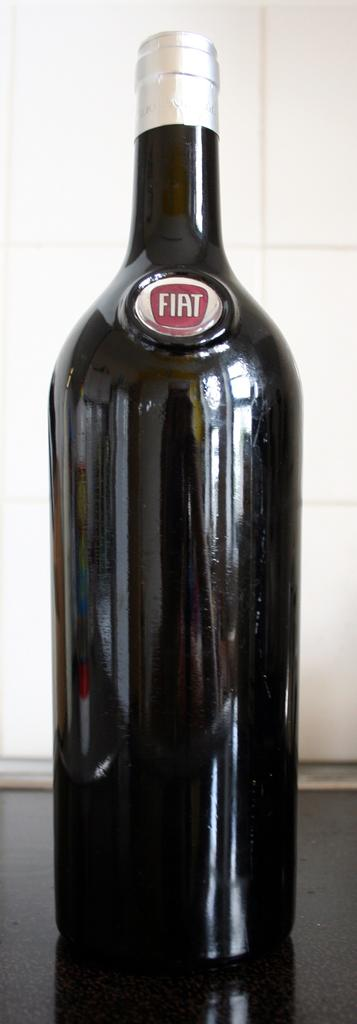<image>
Provide a brief description of the given image. "FIAT" is written on the top of a black bottle. 